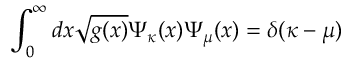<formula> <loc_0><loc_0><loc_500><loc_500>\int _ { 0 } ^ { \infty } d x \sqrt { g ( x ) } \Psi _ { \kappa } ( x ) \Psi _ { \mu } ( x ) = \delta ( \kappa - \mu )</formula> 